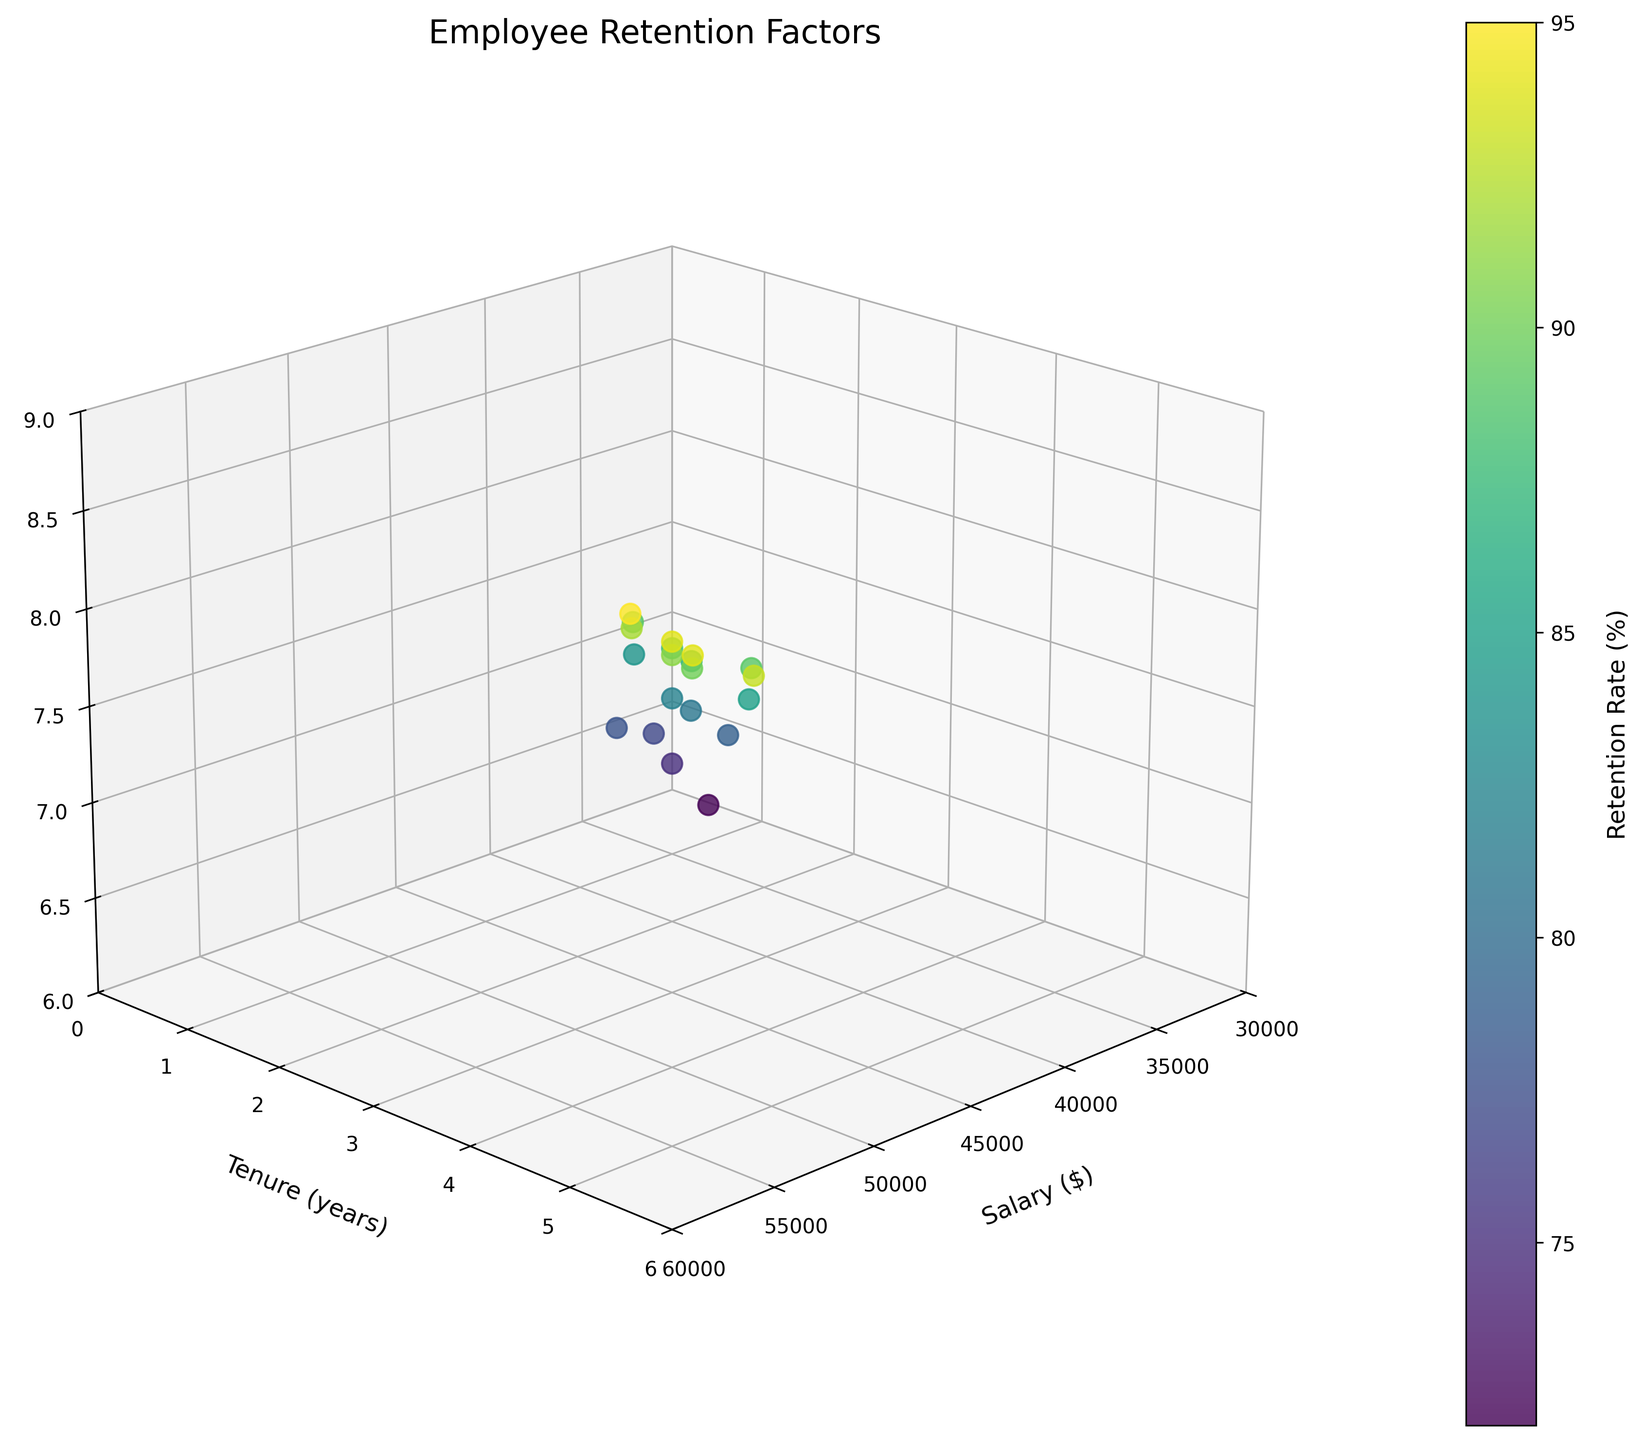What's the title of the 3D plot? The title of the 3D plot is displayed at the top of the figure, in the largest font size and bold text, immediately providing context.
Answer: Employee Retention Factors What do the colors in the plot represent? The color of each data point in the scatter plot corresponds to the value of the retention rate, as indicated by the color bar on the right side of the plot.
Answer: Retention Rate What range of salaries is shown on the x-axis? The x-axis is labeled "Salary ($)" with a range that visually spans from $30000 to $60000, providing context for the data points.
Answer: $30000 to $60000 How many data points are plotted in the 3D scatter plot? By counting each visible point within the 3D plot, we identify each distinct combination of (Salary, Tenure, Job Satisfaction).
Answer: 20 Which data point has the highest job satisfaction and what is its retention rate? The data point with the highest job satisfaction can be identified by looking for the largest value along the z-axis (Job Satisfaction). The color of this point, corresponding to the retention rate, can then be identified in the color bar legend.
Answer: 8.7, 95% What is the average retention rate for employees with a tenure of 3 years? Look at all data points where the y-axis value (Tenure) is 3 years, and calculate the mean of their retention rates. Retention rates for 3-year tenure are: 88, 85, 87, and 89. Average = (88 + 85 + 87 + 89) / 4
Answer: 87.25% Do higher salaries correspond to higher job satisfaction levels? Examine the trend along the x-axis (Salary) and z-axis (Job Satisfaction) to determine if higher salaries generally relate to higher levels of job satisfaction in the plot.
Answer: Yes, generally Is there a clear trend in retention rates among employees with different salaries? Compare the distribution of colors as they correspond to different salary ranges on the color bar. Look for gradients indicating a pattern.
Answer: Yes, higher salaries generally show higher retention rates Which factor (Salary, Tenure, or Job Satisfaction) seems to show the most variation in terms of its effect on retention rates? Observe the spread and color changes in each axis to determine which factor correlates strongly with the variations in retention rates, noting the overall trends and color contrasts.
Answer: Salary 